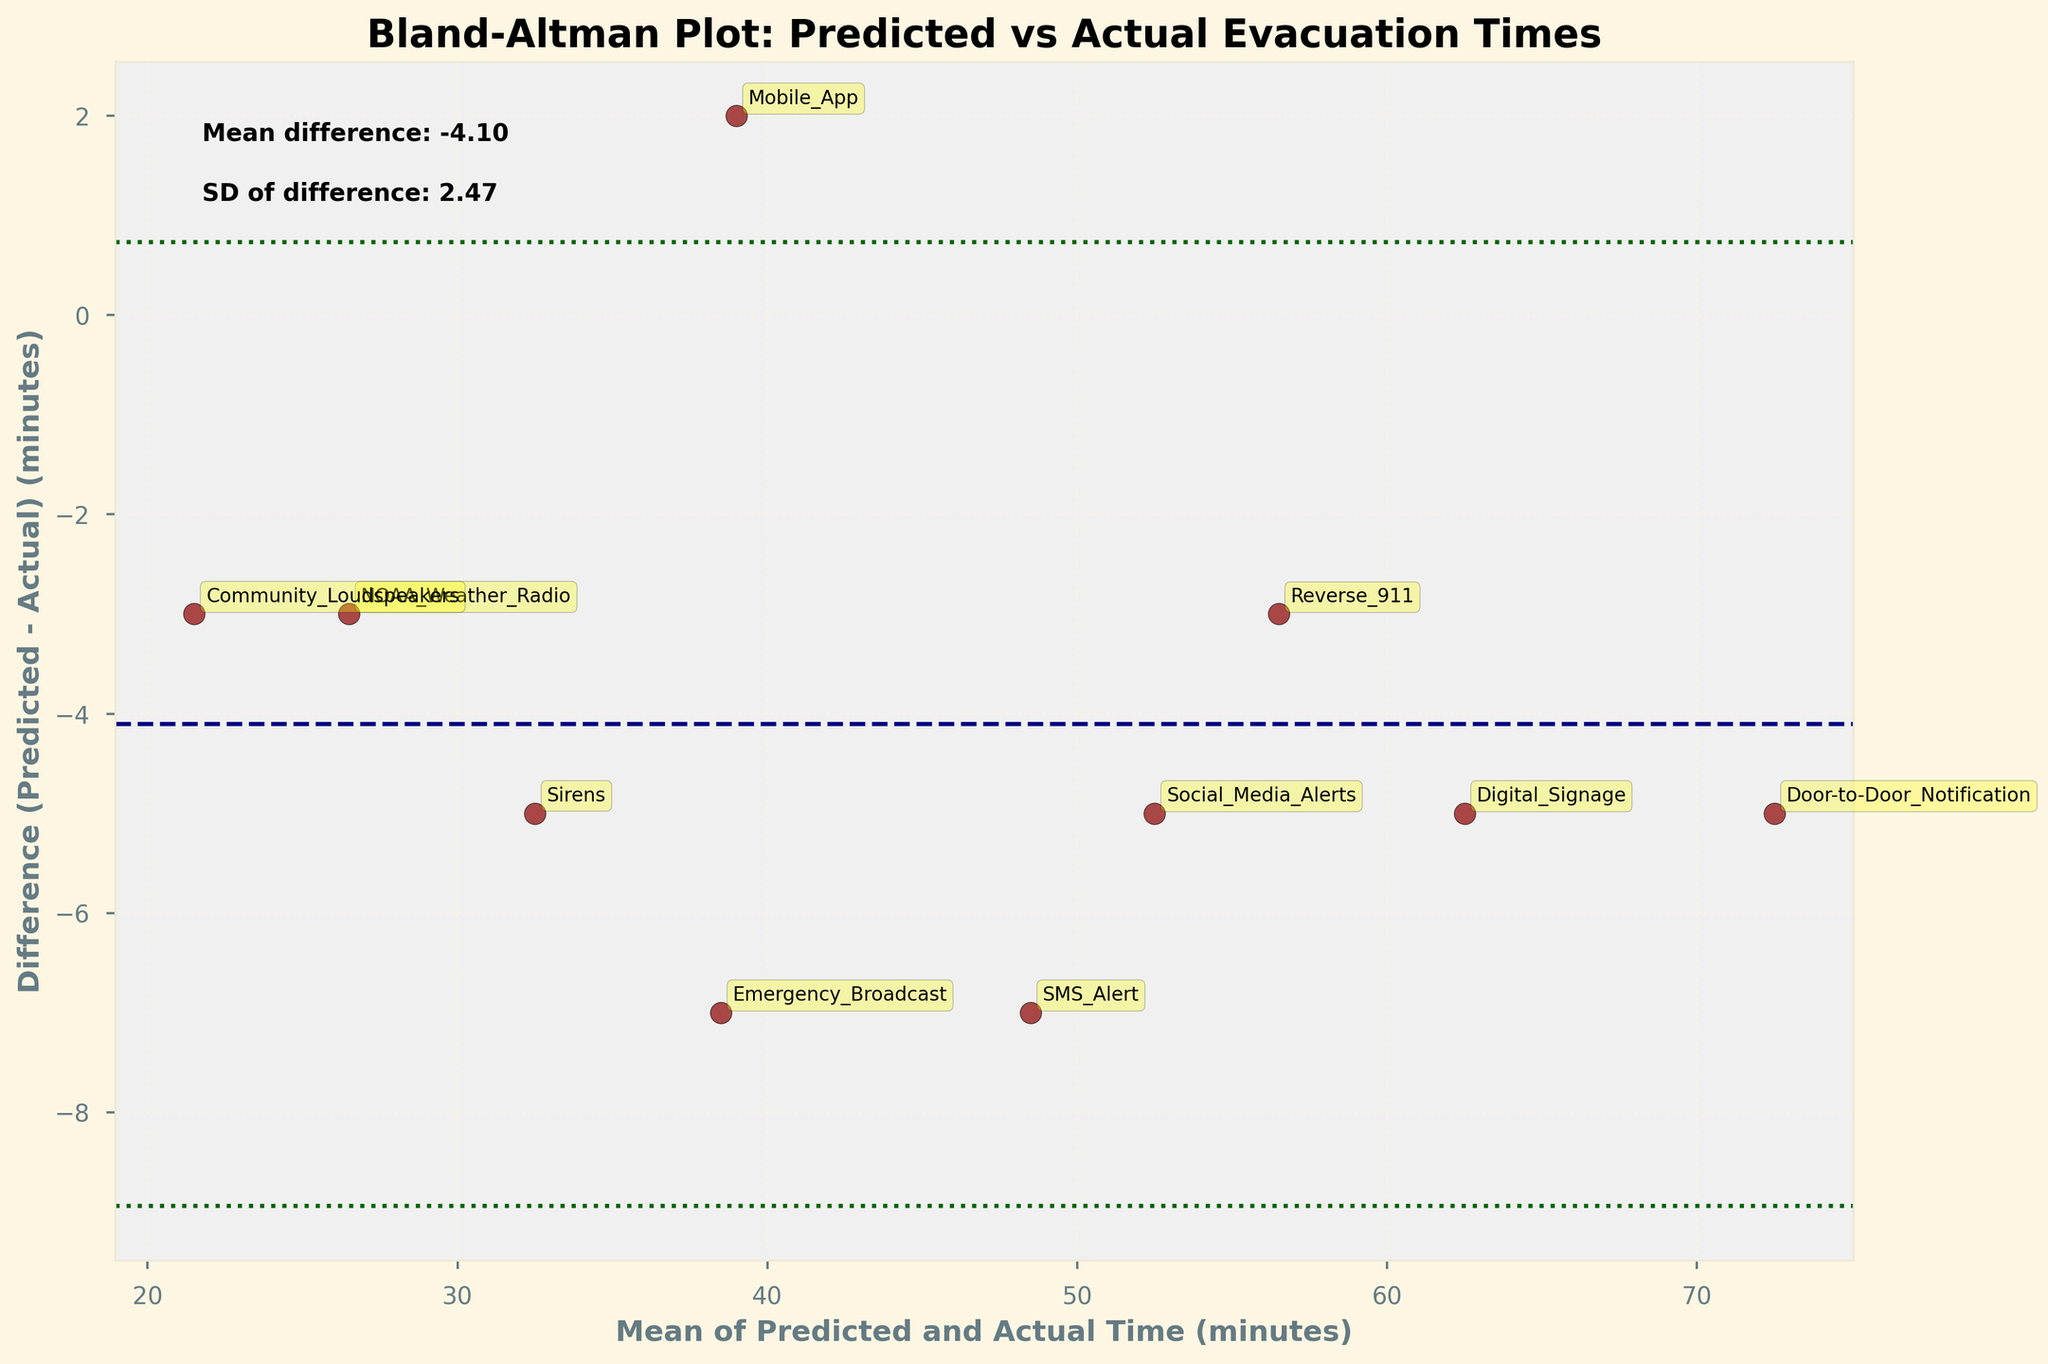What is the title of the figure? The title is usually placed at the top of the figure. In this case, the title clearly states the purpose of the plot.
Answer: Bland-Altman Plot: Predicted vs Actual Evacuation Times How many emergency alert systems are compared in this figure? Count each individual point on the plot which corresponds to different alert systems. Each point represents one system.
Answer: 10 What are the units on the X-axis? The units for the X-axis can be found in the axis label. It is the average of predicted and actual times.
Answer: Minutes Which evacuation system has the largest negative difference between predicted and actual times? Look for the point with the most significant negative value on the Y-axis and identify the label.
Answer: Mobile App What's the mean of the differences between predicted and actual evacuation times? The mean difference is shown as a horizontal dashed line, accompanied by a textual annotation indicating the value.
Answer: -0.20 Which alert system shows the smallest absolute difference between predicted and actual times? Identify the point closest to the X-axis (0 value) and note the corresponding label.
Answer: NOAA Weather Radio What does the dashed line in the plot represent? This line is usually indicative of the mean difference between predicted and actual times, as annotated beside the line.
Answer: Mean difference Does the Reverse 911 system have a positive or negative difference between predicted and actual times? Observe the position of the 'Reverse 911' label relative to the X-axis. Above means positive, below means negative.
Answer: Positive Which systems lie within the limits of agreement? Systems falling between the two green dotted lines (limits of agreement) are considered within. Identify and list these systems.
Answer: SMS Alert, Sirens, Mobile App, Emergency Broadcast, Social Media Alerts, Reverse 911, NOAA Weather Radio, Digital Signage, Door-to-Door Notification, Community Loudspeakers What are the limits of agreement in the plot? The limits of agreement are denoted by dotted lines, calculated as mean difference ± 1.96 times the standard deviation. Their exact values are given by the annotations.
Answer: Approximately 4.14 and -4.54 